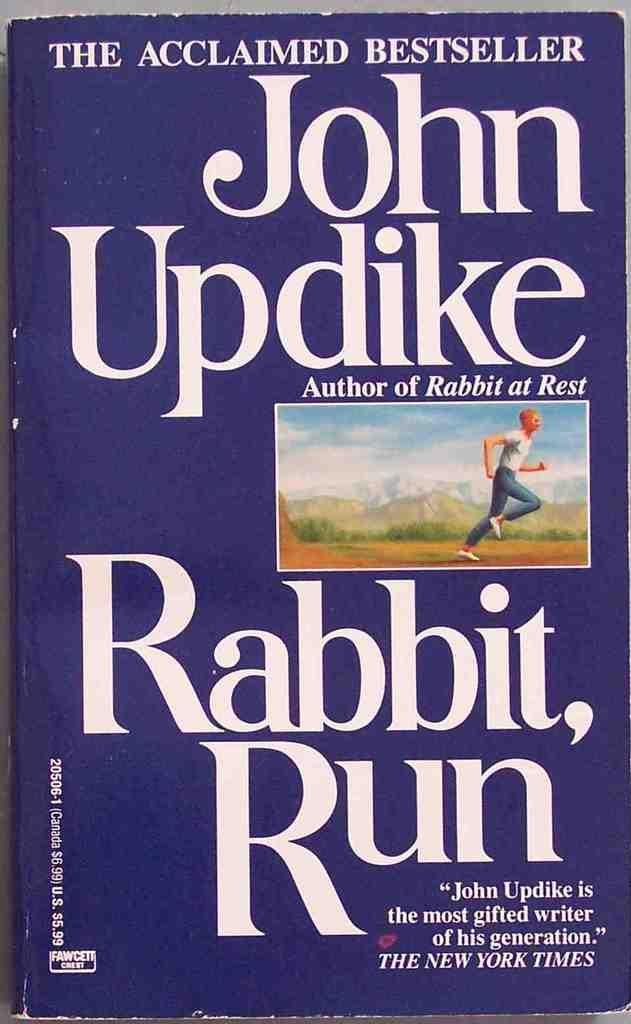<image>
Share a concise interpretation of the image provided. The book is called Rabbit Run written by John Updike 